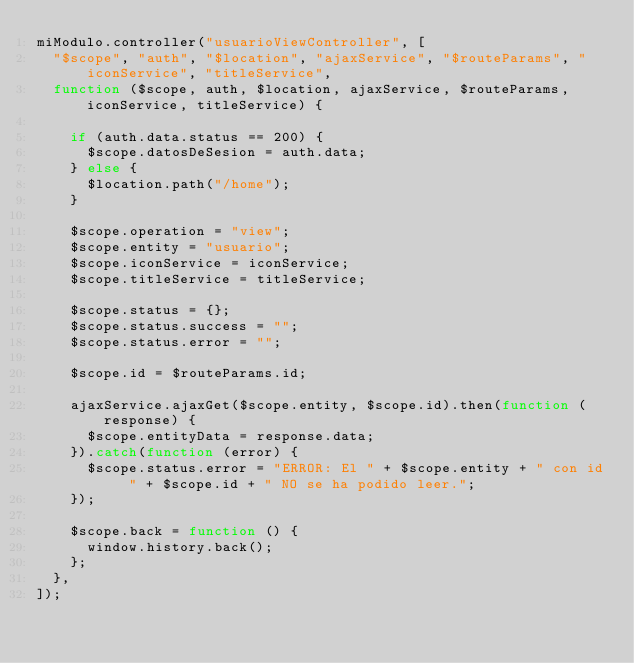Convert code to text. <code><loc_0><loc_0><loc_500><loc_500><_JavaScript_>miModulo.controller("usuarioViewController", [
  "$scope", "auth", "$location", "ajaxService", "$routeParams", "iconService", "titleService",
  function ($scope, auth, $location, ajaxService, $routeParams, iconService, titleService) {

    if (auth.data.status == 200) {
      $scope.datosDeSesion = auth.data;
    } else {
      $location.path("/home");
    }

    $scope.operation = "view";
    $scope.entity = "usuario";
    $scope.iconService = iconService;
    $scope.titleService = titleService;

    $scope.status = {};
    $scope.status.success = "";
    $scope.status.error = "";

    $scope.id = $routeParams.id;

    ajaxService.ajaxGet($scope.entity, $scope.id).then(function (response) {
      $scope.entityData = response.data;
    }).catch(function (error) {
      $scope.status.error = "ERROR: El " + $scope.entity + " con id " + $scope.id + " NO se ha podido leer.";
    });

    $scope.back = function () {
      window.history.back();
    };
  },
]);
</code> 